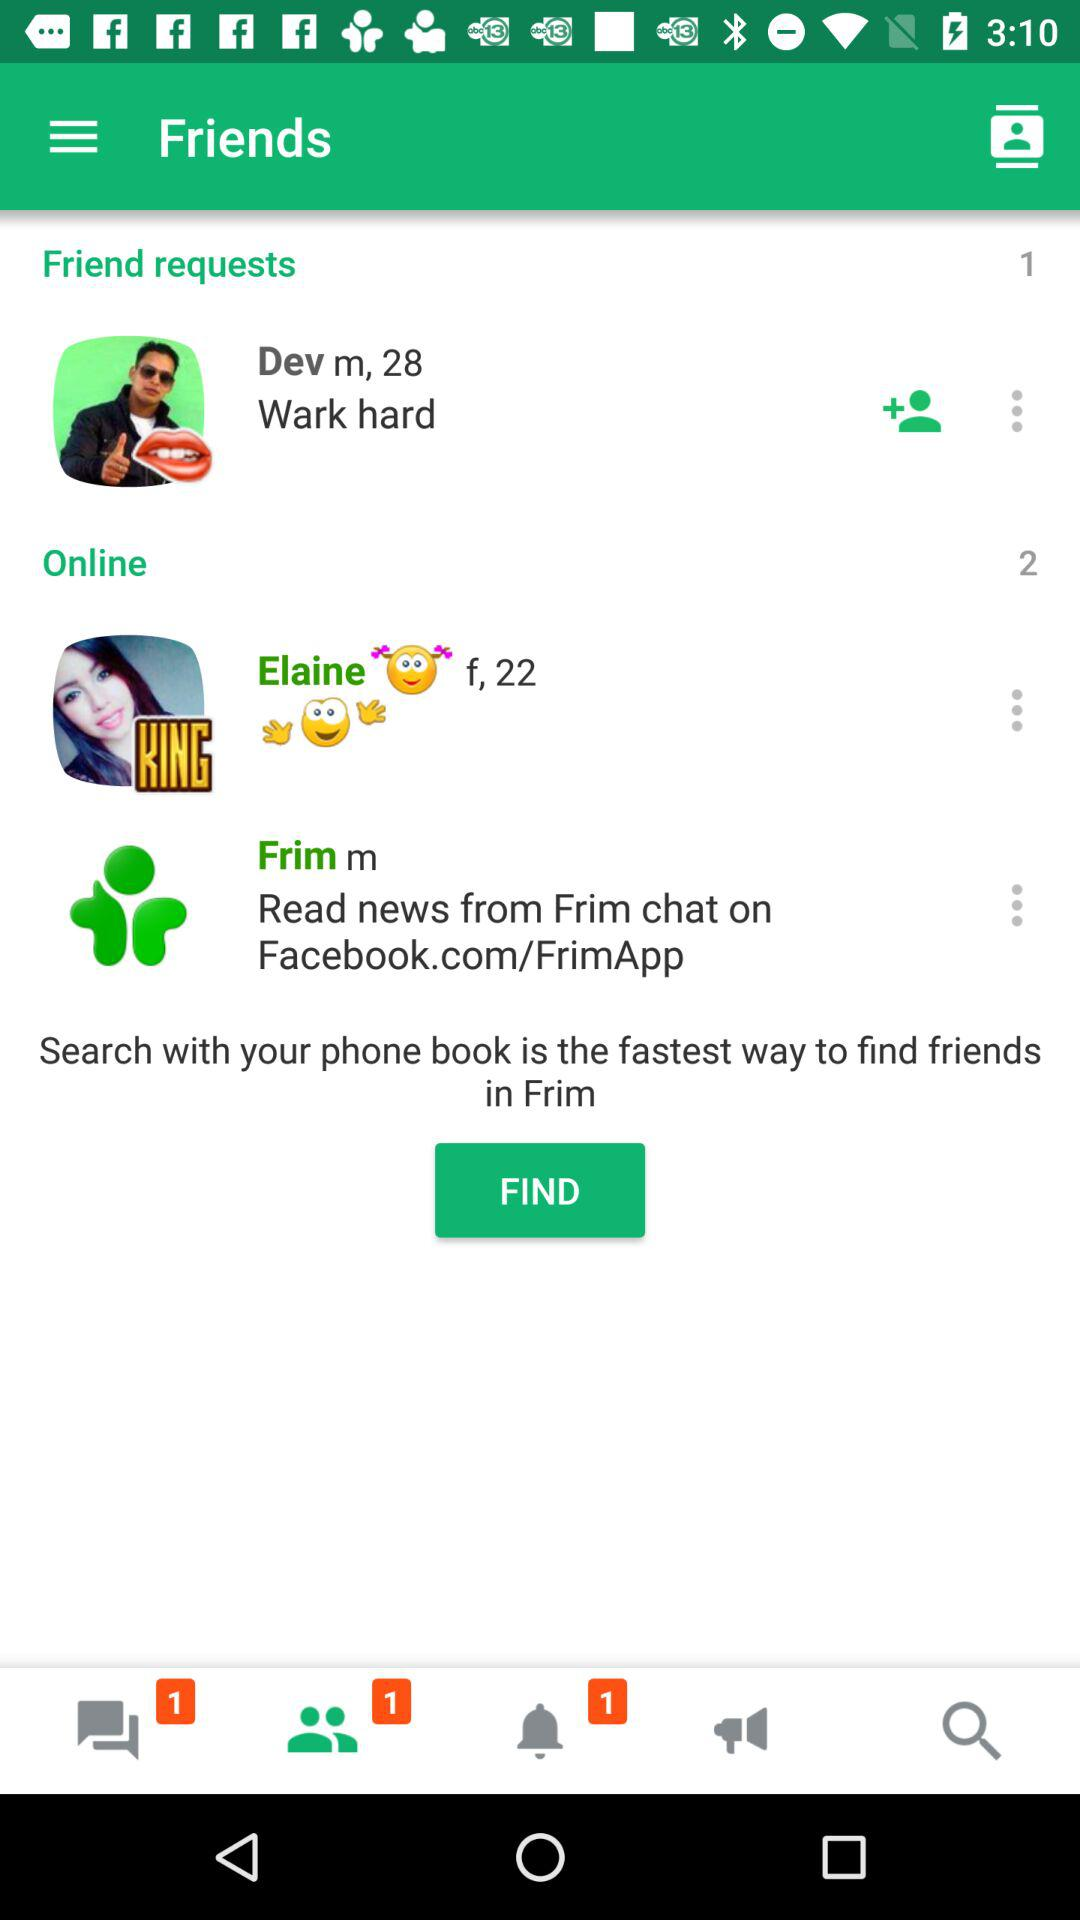What is the age of Elaine? Elaine is 22 years old. 